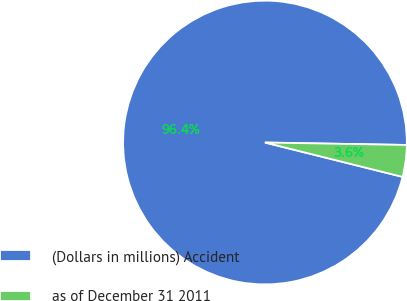<chart> <loc_0><loc_0><loc_500><loc_500><pie_chart><fcel>(Dollars in millions) Accident<fcel>as of December 31 2011<nl><fcel>96.38%<fcel>3.62%<nl></chart> 